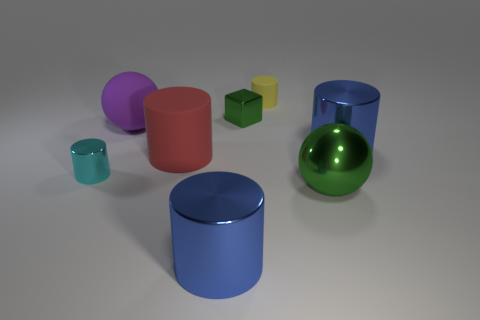Subtract all cyan cylinders. How many cylinders are left? 4 Subtract all rubber cylinders. How many cylinders are left? 3 Subtract all green cylinders. Subtract all brown blocks. How many cylinders are left? 5 Add 1 small yellow matte cylinders. How many objects exist? 9 Subtract all cylinders. How many objects are left? 3 Subtract 0 brown cylinders. How many objects are left? 8 Subtract all red things. Subtract all big matte cylinders. How many objects are left? 6 Add 5 small yellow things. How many small yellow things are left? 6 Add 3 red cylinders. How many red cylinders exist? 4 